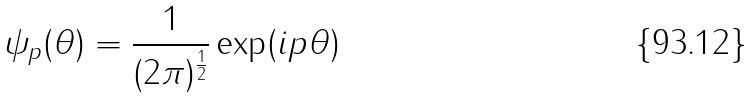Convert formula to latex. <formula><loc_0><loc_0><loc_500><loc_500>\psi _ { p } ( \theta ) = \frac { 1 } { ( 2 \pi ) ^ { \frac { 1 } { 2 } } } \exp ( i p \theta )</formula> 